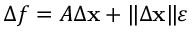Convert formula to latex. <formula><loc_0><loc_0><loc_500><loc_500>\Delta f = A \Delta x + \| \Delta x \| { \varepsilon }</formula> 